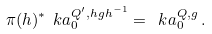Convert formula to latex. <formula><loc_0><loc_0><loc_500><loc_500>\pi ( h ) ^ { * } \ k a ^ { Q ^ { \prime } , h g h ^ { - 1 } } _ { 0 } = \ k a ^ { Q , g } _ { 0 } \, .</formula> 